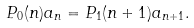<formula> <loc_0><loc_0><loc_500><loc_500>P _ { 0 } ( n ) a _ { n } = P _ { 1 } ( n + 1 ) a _ { n + 1 } .</formula> 